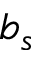Convert formula to latex. <formula><loc_0><loc_0><loc_500><loc_500>b _ { s }</formula> 